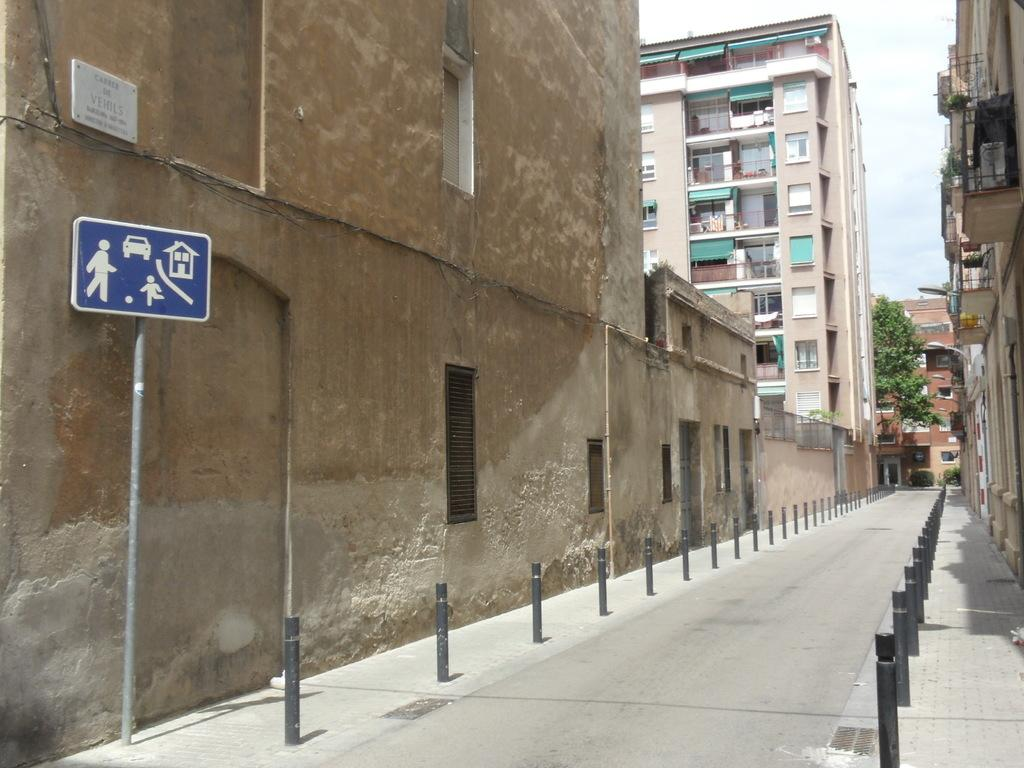What is the main feature of the image? There is a road in the image. What else can be seen along the road? There are black rods and buildings on either side of the road. What is visible in the background of the image? There is a tree in the background of the image. What type of tin can be seen on the train in the image? There is no train present in the image, so there is no tin to be seen. 